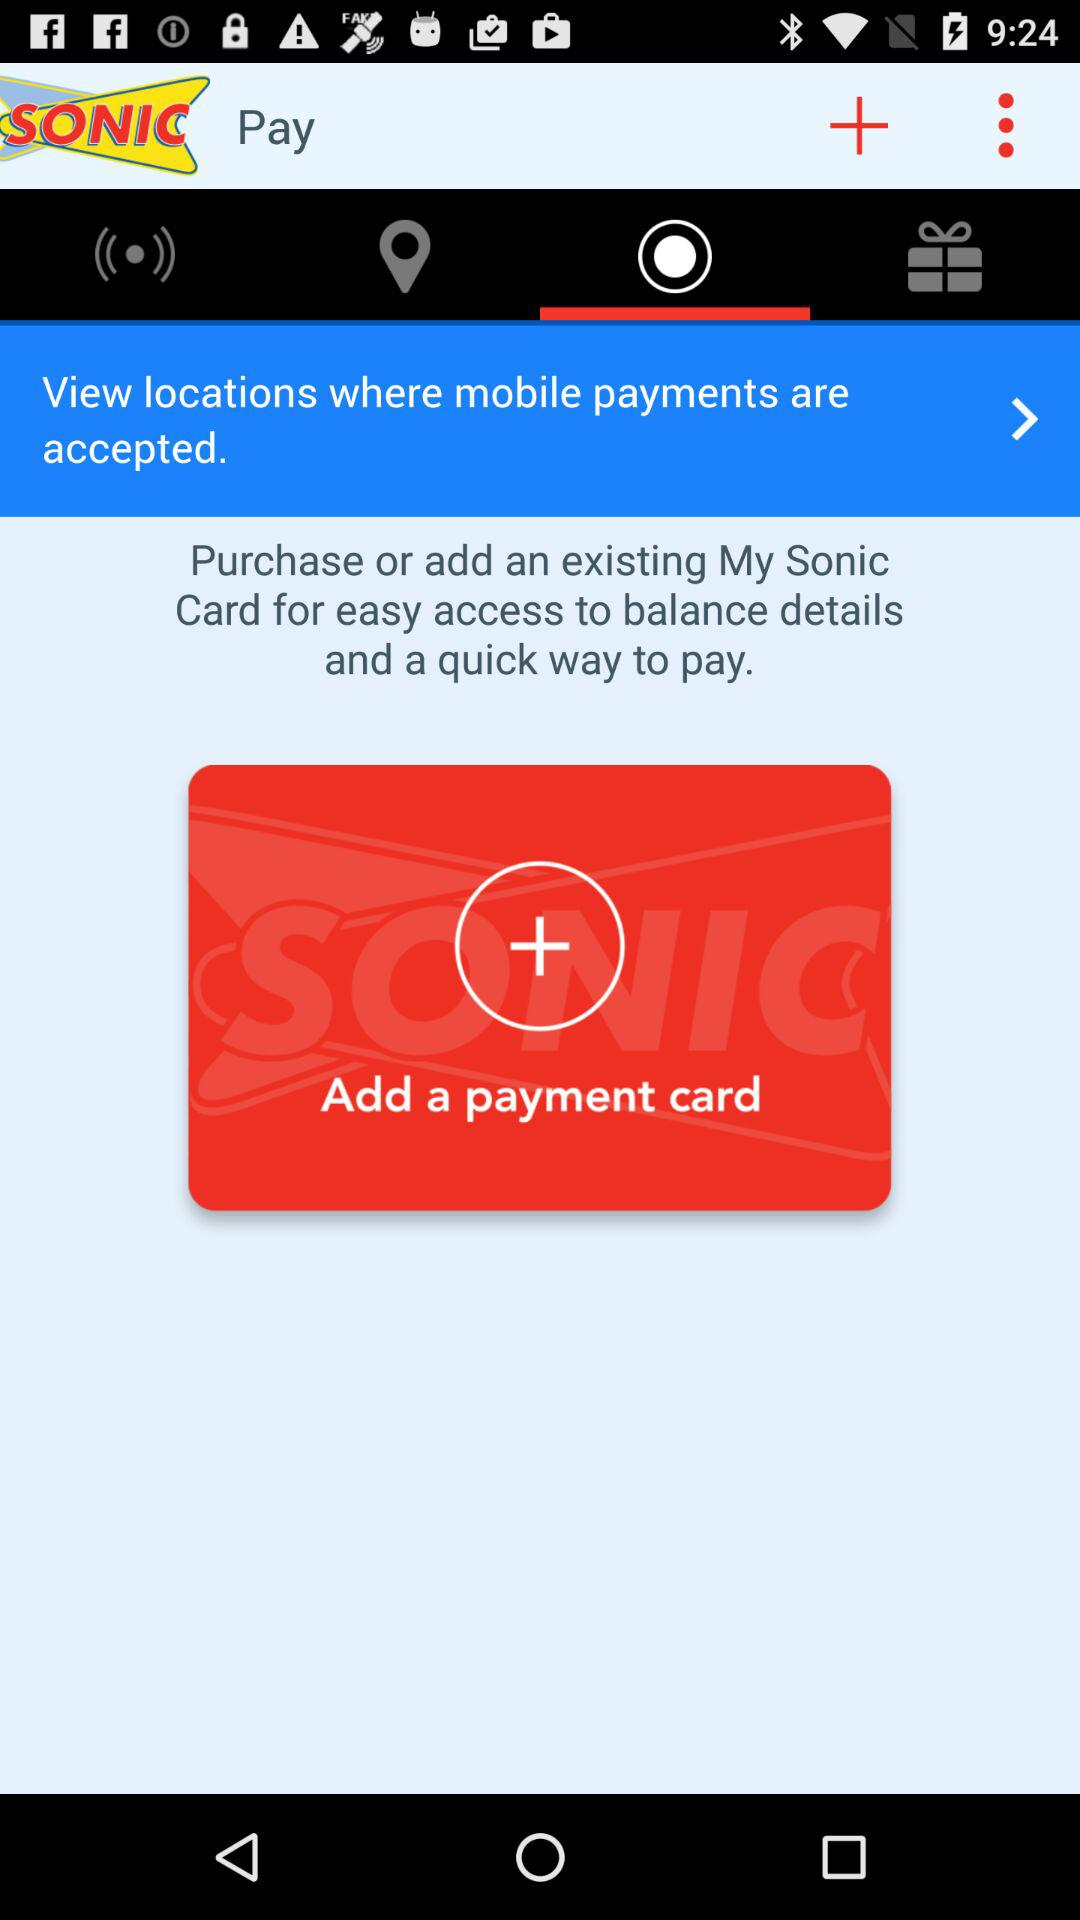What is the name of the application? The name of the application is "SONIC". 